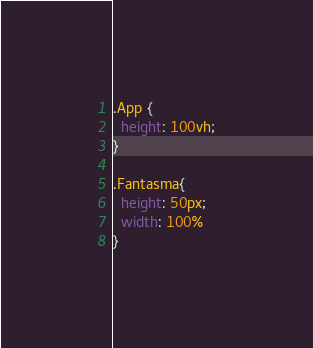Convert code to text. <code><loc_0><loc_0><loc_500><loc_500><_CSS_>.App {
  height: 100vh;
}

.Fantasma{
  height: 50px;
  width: 100%
}
</code> 